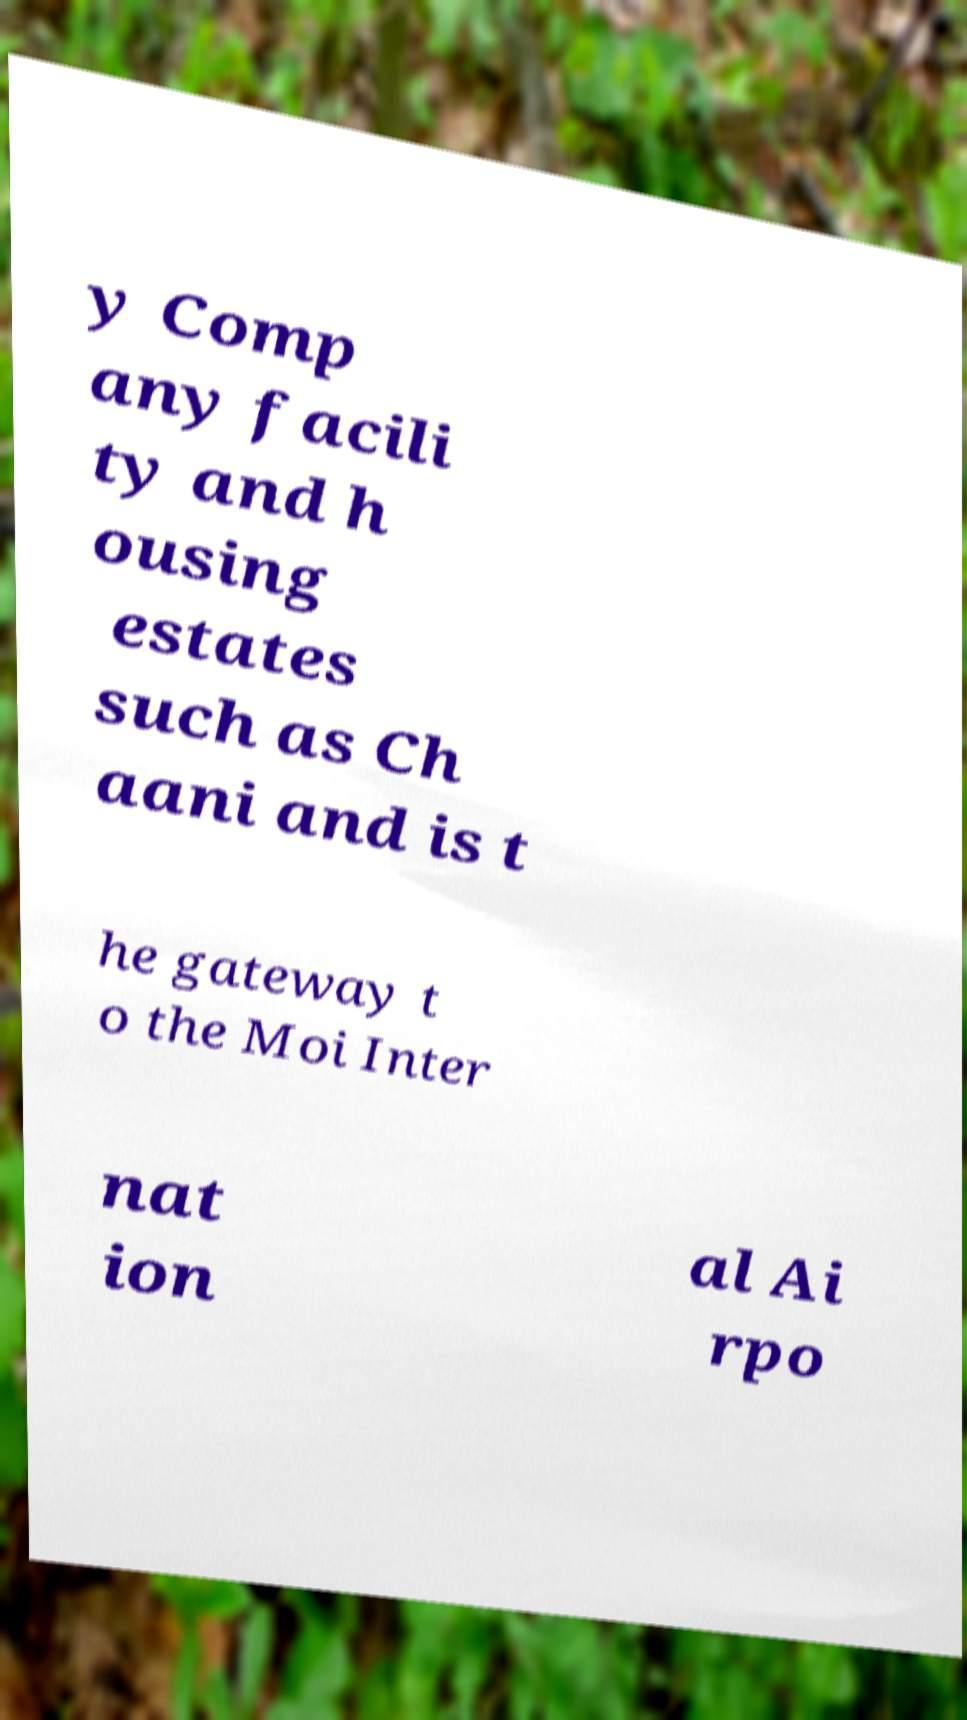Please read and relay the text visible in this image. What does it say? y Comp any facili ty and h ousing estates such as Ch aani and is t he gateway t o the Moi Inter nat ion al Ai rpo 